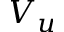Convert formula to latex. <formula><loc_0><loc_0><loc_500><loc_500>V _ { u }</formula> 